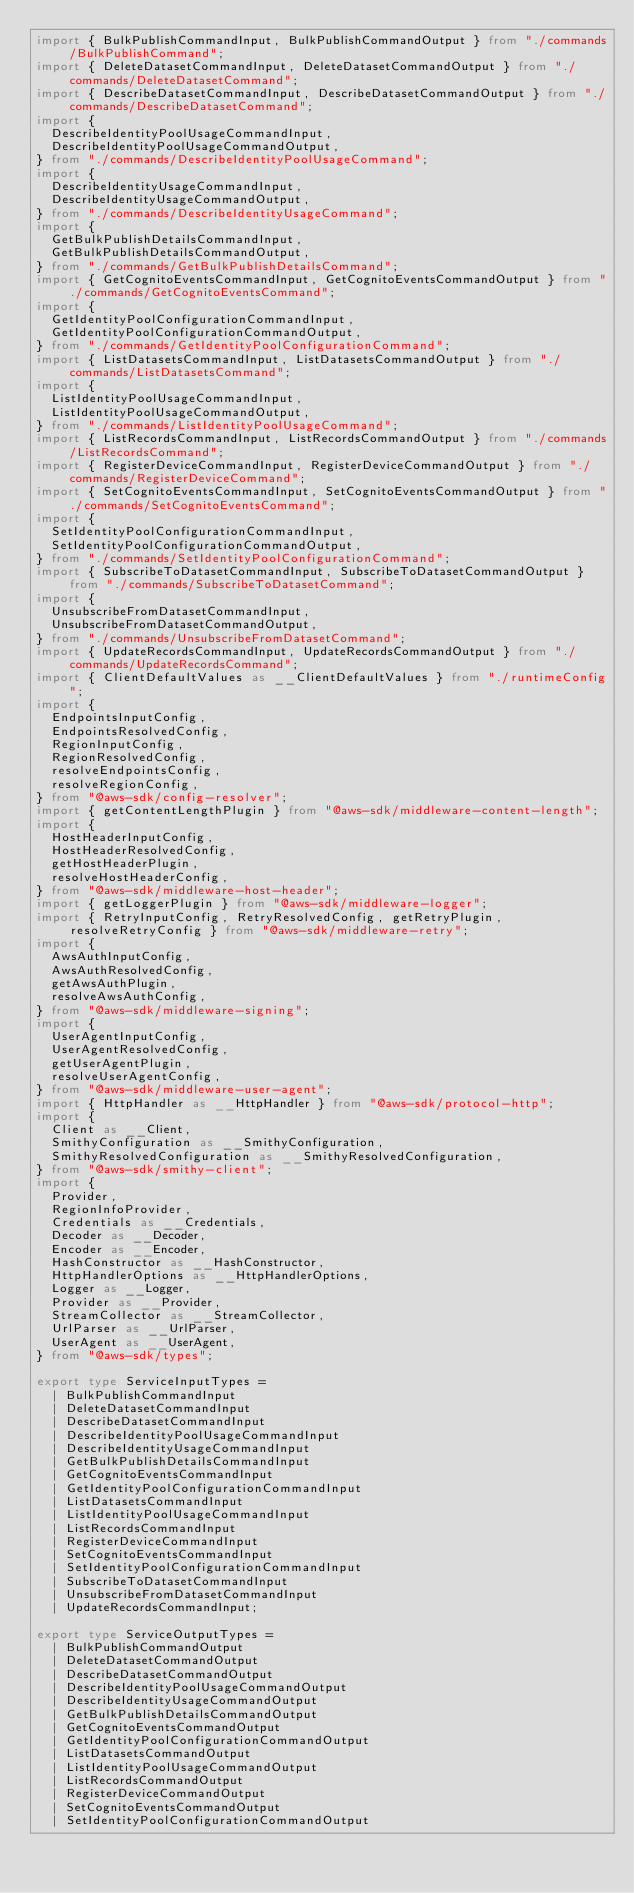<code> <loc_0><loc_0><loc_500><loc_500><_TypeScript_>import { BulkPublishCommandInput, BulkPublishCommandOutput } from "./commands/BulkPublishCommand";
import { DeleteDatasetCommandInput, DeleteDatasetCommandOutput } from "./commands/DeleteDatasetCommand";
import { DescribeDatasetCommandInput, DescribeDatasetCommandOutput } from "./commands/DescribeDatasetCommand";
import {
  DescribeIdentityPoolUsageCommandInput,
  DescribeIdentityPoolUsageCommandOutput,
} from "./commands/DescribeIdentityPoolUsageCommand";
import {
  DescribeIdentityUsageCommandInput,
  DescribeIdentityUsageCommandOutput,
} from "./commands/DescribeIdentityUsageCommand";
import {
  GetBulkPublishDetailsCommandInput,
  GetBulkPublishDetailsCommandOutput,
} from "./commands/GetBulkPublishDetailsCommand";
import { GetCognitoEventsCommandInput, GetCognitoEventsCommandOutput } from "./commands/GetCognitoEventsCommand";
import {
  GetIdentityPoolConfigurationCommandInput,
  GetIdentityPoolConfigurationCommandOutput,
} from "./commands/GetIdentityPoolConfigurationCommand";
import { ListDatasetsCommandInput, ListDatasetsCommandOutput } from "./commands/ListDatasetsCommand";
import {
  ListIdentityPoolUsageCommandInput,
  ListIdentityPoolUsageCommandOutput,
} from "./commands/ListIdentityPoolUsageCommand";
import { ListRecordsCommandInput, ListRecordsCommandOutput } from "./commands/ListRecordsCommand";
import { RegisterDeviceCommandInput, RegisterDeviceCommandOutput } from "./commands/RegisterDeviceCommand";
import { SetCognitoEventsCommandInput, SetCognitoEventsCommandOutput } from "./commands/SetCognitoEventsCommand";
import {
  SetIdentityPoolConfigurationCommandInput,
  SetIdentityPoolConfigurationCommandOutput,
} from "./commands/SetIdentityPoolConfigurationCommand";
import { SubscribeToDatasetCommandInput, SubscribeToDatasetCommandOutput } from "./commands/SubscribeToDatasetCommand";
import {
  UnsubscribeFromDatasetCommandInput,
  UnsubscribeFromDatasetCommandOutput,
} from "./commands/UnsubscribeFromDatasetCommand";
import { UpdateRecordsCommandInput, UpdateRecordsCommandOutput } from "./commands/UpdateRecordsCommand";
import { ClientDefaultValues as __ClientDefaultValues } from "./runtimeConfig";
import {
  EndpointsInputConfig,
  EndpointsResolvedConfig,
  RegionInputConfig,
  RegionResolvedConfig,
  resolveEndpointsConfig,
  resolveRegionConfig,
} from "@aws-sdk/config-resolver";
import { getContentLengthPlugin } from "@aws-sdk/middleware-content-length";
import {
  HostHeaderInputConfig,
  HostHeaderResolvedConfig,
  getHostHeaderPlugin,
  resolveHostHeaderConfig,
} from "@aws-sdk/middleware-host-header";
import { getLoggerPlugin } from "@aws-sdk/middleware-logger";
import { RetryInputConfig, RetryResolvedConfig, getRetryPlugin, resolveRetryConfig } from "@aws-sdk/middleware-retry";
import {
  AwsAuthInputConfig,
  AwsAuthResolvedConfig,
  getAwsAuthPlugin,
  resolveAwsAuthConfig,
} from "@aws-sdk/middleware-signing";
import {
  UserAgentInputConfig,
  UserAgentResolvedConfig,
  getUserAgentPlugin,
  resolveUserAgentConfig,
} from "@aws-sdk/middleware-user-agent";
import { HttpHandler as __HttpHandler } from "@aws-sdk/protocol-http";
import {
  Client as __Client,
  SmithyConfiguration as __SmithyConfiguration,
  SmithyResolvedConfiguration as __SmithyResolvedConfiguration,
} from "@aws-sdk/smithy-client";
import {
  Provider,
  RegionInfoProvider,
  Credentials as __Credentials,
  Decoder as __Decoder,
  Encoder as __Encoder,
  HashConstructor as __HashConstructor,
  HttpHandlerOptions as __HttpHandlerOptions,
  Logger as __Logger,
  Provider as __Provider,
  StreamCollector as __StreamCollector,
  UrlParser as __UrlParser,
  UserAgent as __UserAgent,
} from "@aws-sdk/types";

export type ServiceInputTypes =
  | BulkPublishCommandInput
  | DeleteDatasetCommandInput
  | DescribeDatasetCommandInput
  | DescribeIdentityPoolUsageCommandInput
  | DescribeIdentityUsageCommandInput
  | GetBulkPublishDetailsCommandInput
  | GetCognitoEventsCommandInput
  | GetIdentityPoolConfigurationCommandInput
  | ListDatasetsCommandInput
  | ListIdentityPoolUsageCommandInput
  | ListRecordsCommandInput
  | RegisterDeviceCommandInput
  | SetCognitoEventsCommandInput
  | SetIdentityPoolConfigurationCommandInput
  | SubscribeToDatasetCommandInput
  | UnsubscribeFromDatasetCommandInput
  | UpdateRecordsCommandInput;

export type ServiceOutputTypes =
  | BulkPublishCommandOutput
  | DeleteDatasetCommandOutput
  | DescribeDatasetCommandOutput
  | DescribeIdentityPoolUsageCommandOutput
  | DescribeIdentityUsageCommandOutput
  | GetBulkPublishDetailsCommandOutput
  | GetCognitoEventsCommandOutput
  | GetIdentityPoolConfigurationCommandOutput
  | ListDatasetsCommandOutput
  | ListIdentityPoolUsageCommandOutput
  | ListRecordsCommandOutput
  | RegisterDeviceCommandOutput
  | SetCognitoEventsCommandOutput
  | SetIdentityPoolConfigurationCommandOutput</code> 